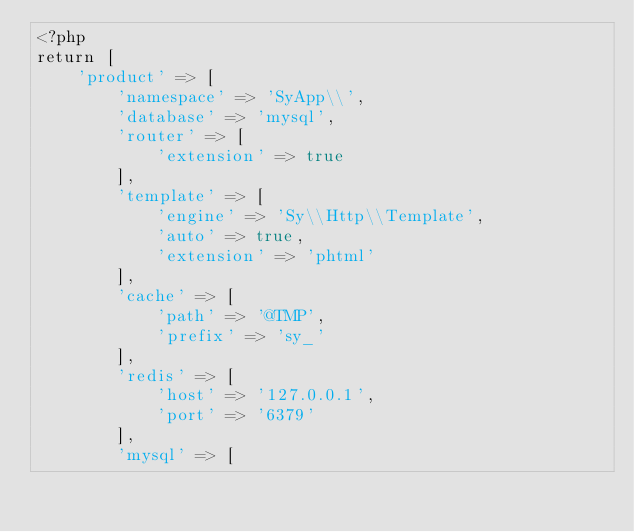Convert code to text. <code><loc_0><loc_0><loc_500><loc_500><_PHP_><?php
return [
	'product' => [
		'namespace' => 'SyApp\\',
		'database' => 'mysql',
		'router' => [
			'extension' => true
		],
		'template' => [
			'engine' => 'Sy\\Http\\Template',
			'auto' => true,
			'extension' => 'phtml'
		],
		'cache' => [
			'path' => '@TMP',
			'prefix' => 'sy_'
		],
		'redis' => [
			'host' => '127.0.0.1',
			'port' => '6379'
		],
		'mysql' => [</code> 